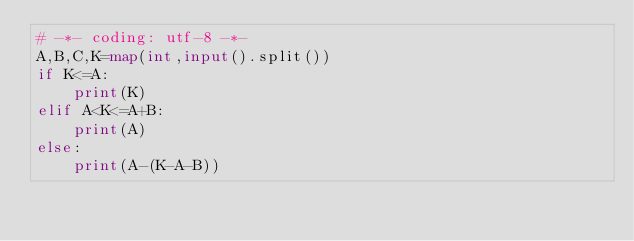<code> <loc_0><loc_0><loc_500><loc_500><_Python_># -*- coding: utf-8 -*-
A,B,C,K=map(int,input().split())
if K<=A:
    print(K)
elif A<K<=A+B:
    print(A)
else:
    print(A-(K-A-B))</code> 